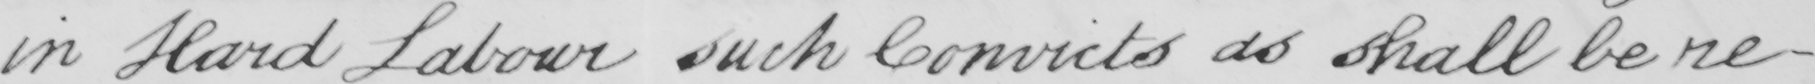What does this handwritten line say? in Hard Labour such Convicts as shall be re- 